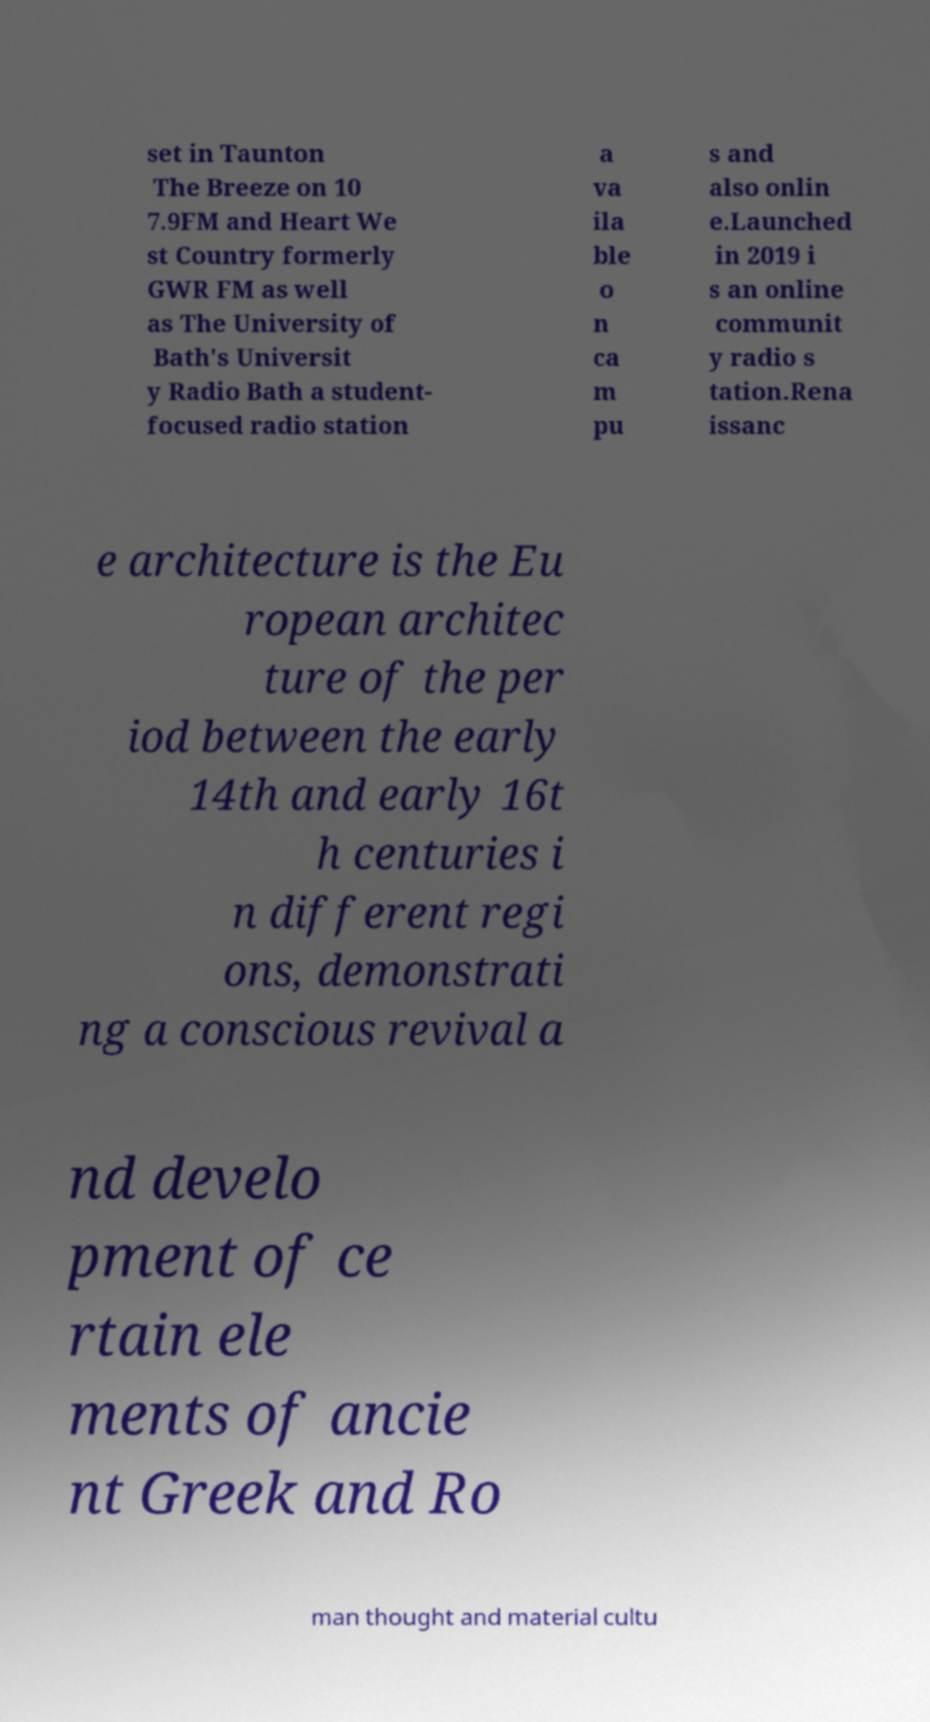Can you read and provide the text displayed in the image?This photo seems to have some interesting text. Can you extract and type it out for me? set in Taunton The Breeze on 10 7.9FM and Heart We st Country formerly GWR FM as well as The University of Bath's Universit y Radio Bath a student- focused radio station a va ila ble o n ca m pu s and also onlin e.Launched in 2019 i s an online communit y radio s tation.Rena issanc e architecture is the Eu ropean architec ture of the per iod between the early 14th and early 16t h centuries i n different regi ons, demonstrati ng a conscious revival a nd develo pment of ce rtain ele ments of ancie nt Greek and Ro man thought and material cultu 